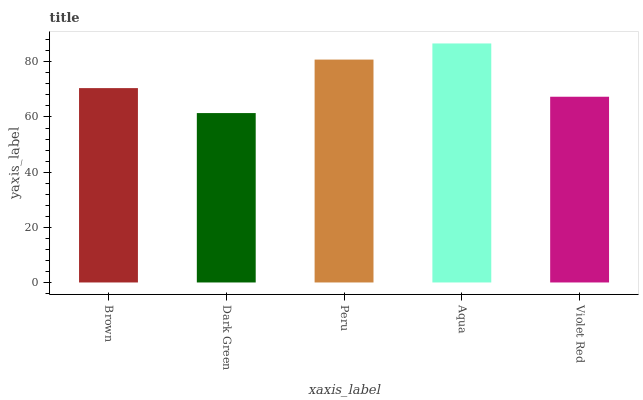Is Dark Green the minimum?
Answer yes or no. Yes. Is Aqua the maximum?
Answer yes or no. Yes. Is Peru the minimum?
Answer yes or no. No. Is Peru the maximum?
Answer yes or no. No. Is Peru greater than Dark Green?
Answer yes or no. Yes. Is Dark Green less than Peru?
Answer yes or no. Yes. Is Dark Green greater than Peru?
Answer yes or no. No. Is Peru less than Dark Green?
Answer yes or no. No. Is Brown the high median?
Answer yes or no. Yes. Is Brown the low median?
Answer yes or no. Yes. Is Violet Red the high median?
Answer yes or no. No. Is Dark Green the low median?
Answer yes or no. No. 